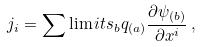<formula> <loc_0><loc_0><loc_500><loc_500>j _ { i } = \sum \lim i t s _ { b } q _ { ( a ) } \frac { \partial \psi _ { ( b ) } } { \partial x ^ { i } } \, ,</formula> 